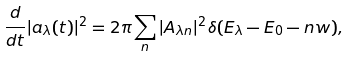Convert formula to latex. <formula><loc_0><loc_0><loc_500><loc_500>\frac { d } { d t } | a _ { \lambda } ( t ) | ^ { 2 } = 2 \pi \sum _ { n } | A _ { \lambda n } | ^ { 2 } \delta ( E _ { \lambda } - E _ { 0 } - n w ) ,</formula> 